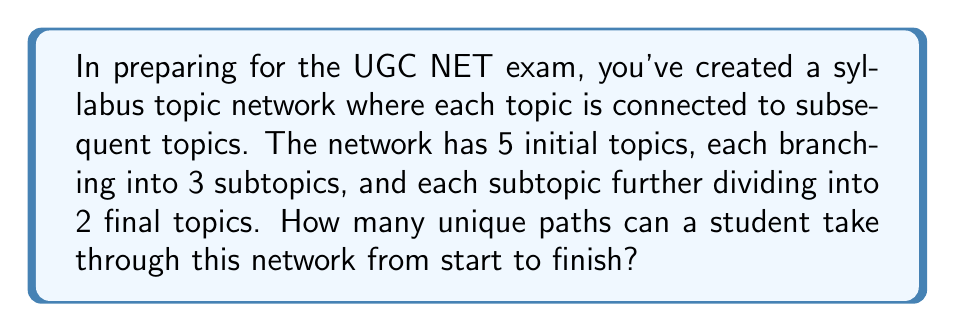Show me your answer to this math problem. Let's approach this step-by-step:

1) First, we need to understand the structure of the network:
   - We start with 5 initial topics
   - Each initial topic leads to 3 subtopics
   - Each subtopic leads to 2 final topics

2) To complete a path, a student must choose:
   - 1 of the 5 initial topics
   - 1 of the 3 subtopics from the chosen initial topic
   - 1 of the 2 final topics from the chosen subtopic

3) We can use the multiplication principle of counting here. The number of unique paths will be:

   $$ \text{Number of paths} = 5 \times 3 \times 2 $$

4) Let's calculate:

   $$ 5 \times 3 \times 2 = 15 \times 2 = 30 $$

Therefore, there are 30 unique paths through this syllabus topic network.

This problem demonstrates the importance of understanding the structure of the syllabus and how topics are interconnected, which is crucial for effective UGC NET exam preparation.
Answer: 30 